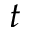<formula> <loc_0><loc_0><loc_500><loc_500>t</formula> 